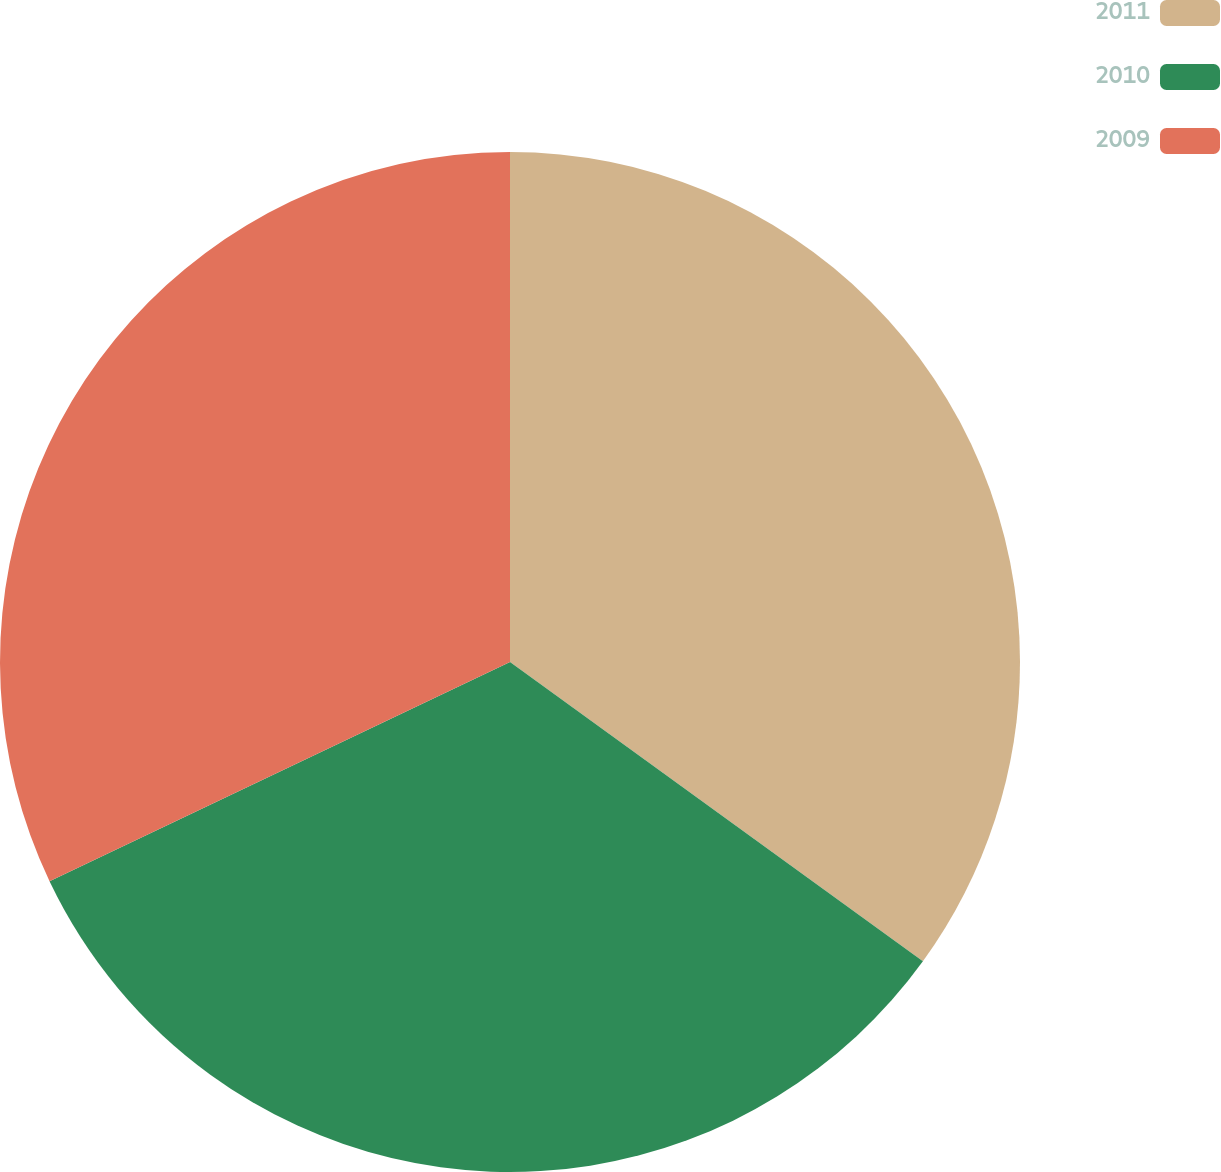Convert chart to OTSL. <chart><loc_0><loc_0><loc_500><loc_500><pie_chart><fcel>2011<fcel>2010<fcel>2009<nl><fcel>34.98%<fcel>32.94%<fcel>32.07%<nl></chart> 